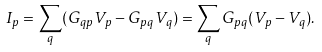Convert formula to latex. <formula><loc_0><loc_0><loc_500><loc_500>I _ { p } = \sum _ { q } ( G _ { q p } V _ { p } - G _ { p q } V _ { q } ) = \sum _ { q } G _ { p q } ( V _ { p } - V _ { q } ) .</formula> 